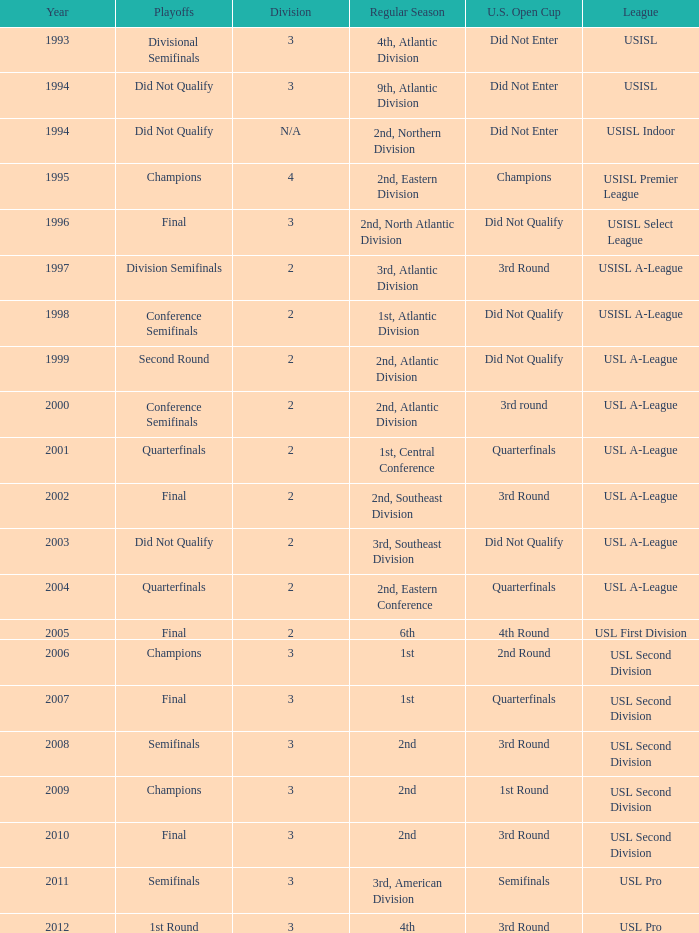How many division  did not qualify for u.s. open cup in 2003 2.0. 